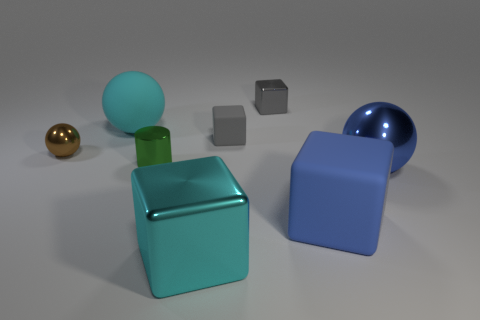What number of brown shiny objects have the same size as the gray rubber block? There is only one brown shiny object in the image, and it does not have the same size as the gray rubber block; it appears to be smaller. Thus, the correct answer is that there are no brown shiny objects that are the same size as the gray rubber block. 